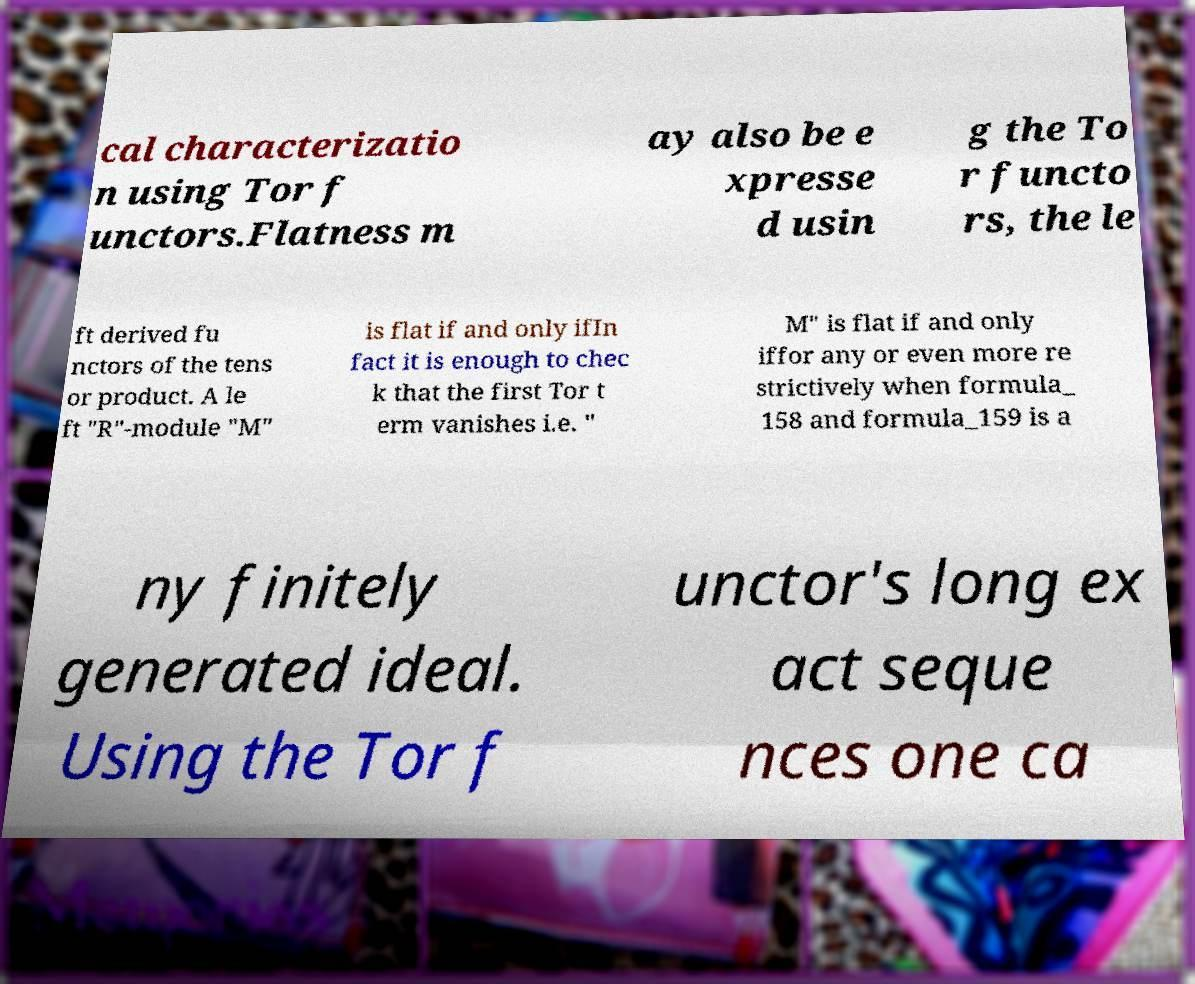Can you read and provide the text displayed in the image?This photo seems to have some interesting text. Can you extract and type it out for me? cal characterizatio n using Tor f unctors.Flatness m ay also be e xpresse d usin g the To r functo rs, the le ft derived fu nctors of the tens or product. A le ft "R"-module "M" is flat if and only ifIn fact it is enough to chec k that the first Tor t erm vanishes i.e. " M" is flat if and only iffor any or even more re strictively when formula_ 158 and formula_159 is a ny finitely generated ideal. Using the Tor f unctor's long ex act seque nces one ca 